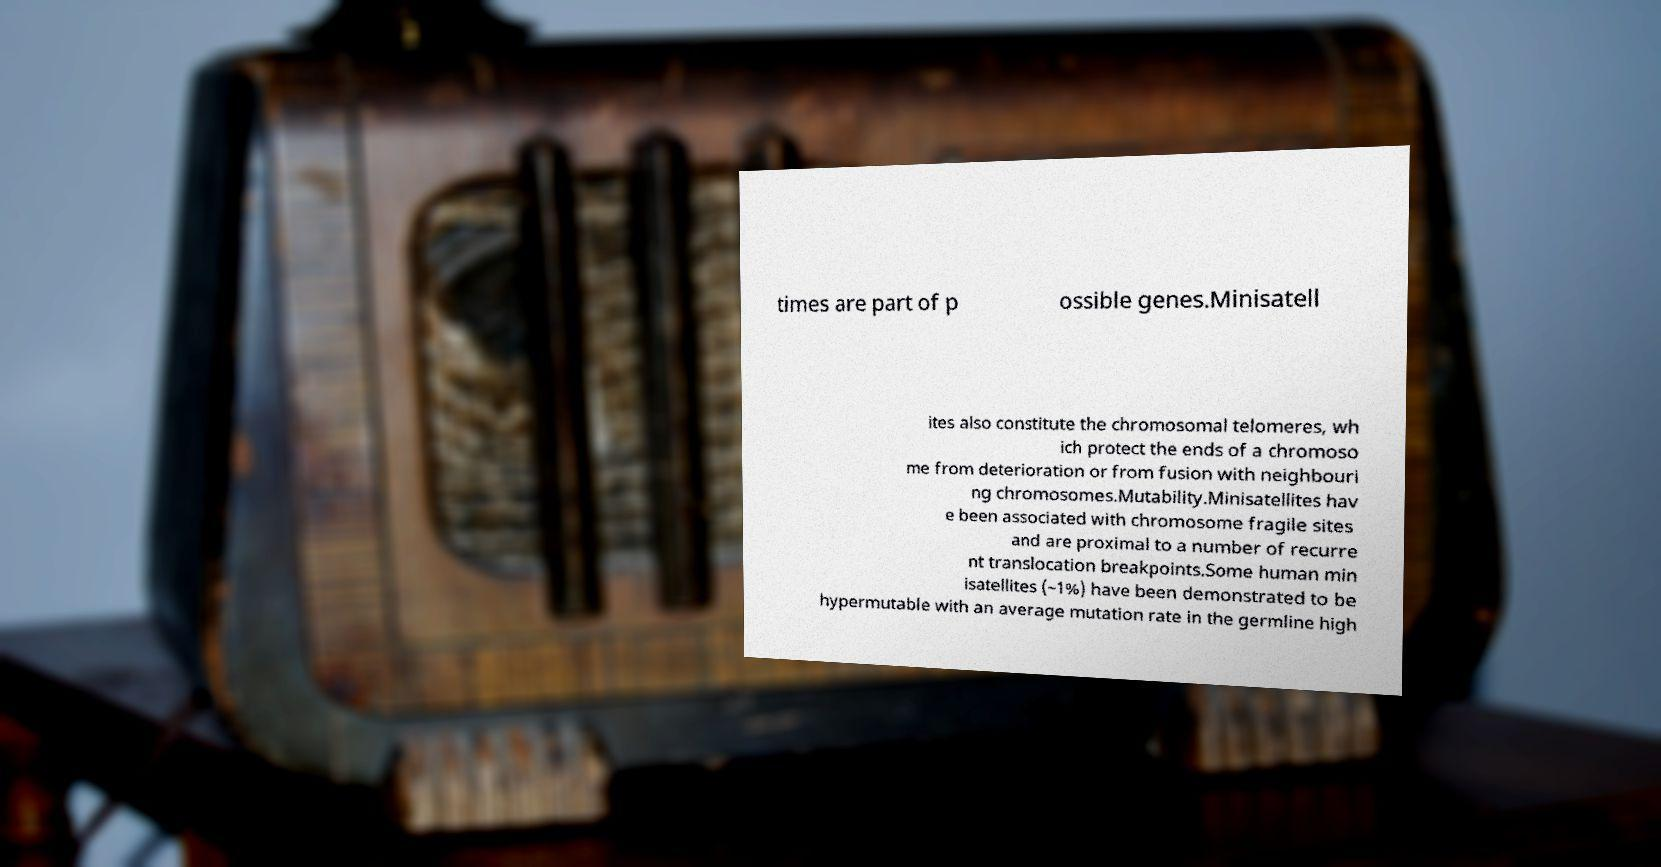Could you assist in decoding the text presented in this image and type it out clearly? times are part of p ossible genes.Minisatell ites also constitute the chromosomal telomeres, wh ich protect the ends of a chromoso me from deterioration or from fusion with neighbouri ng chromosomes.Mutability.Minisatellites hav e been associated with chromosome fragile sites and are proximal to a number of recurre nt translocation breakpoints.Some human min isatellites (~1%) have been demonstrated to be hypermutable with an average mutation rate in the germline high 